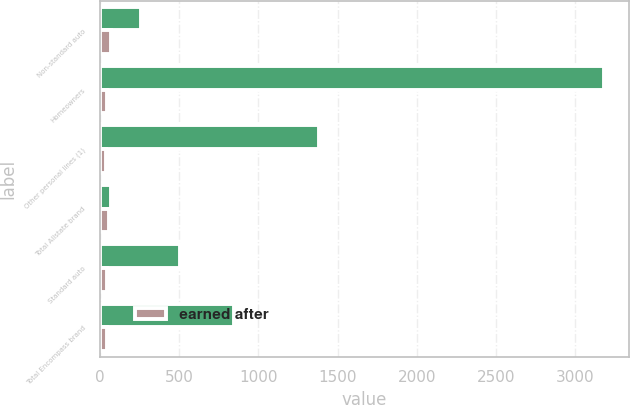Convert chart to OTSL. <chart><loc_0><loc_0><loc_500><loc_500><stacked_bar_chart><ecel><fcel>Non-standard auto<fcel>Homeowners<fcel>Other personal lines (1)<fcel>Total Allstate brand<fcel>Standard auto<fcel>Total Encompass brand<nl><fcel>nan<fcel>259<fcel>3182<fcel>1385<fcel>71.9<fcel>506<fcel>844<nl><fcel>earned after<fcel>71.9<fcel>43.9<fcel>39<fcel>57.6<fcel>44.6<fcel>44.8<nl></chart> 